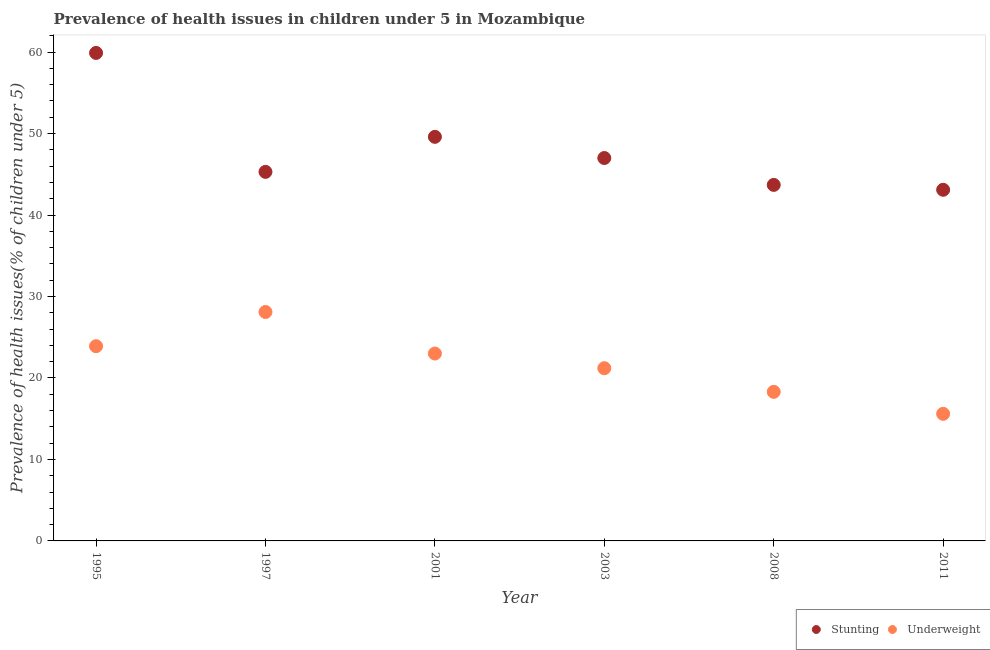Is the number of dotlines equal to the number of legend labels?
Your answer should be compact. Yes. What is the percentage of underweight children in 2001?
Your response must be concise. 23. Across all years, what is the maximum percentage of stunted children?
Keep it short and to the point. 59.9. Across all years, what is the minimum percentage of underweight children?
Make the answer very short. 15.6. In which year was the percentage of stunted children maximum?
Your answer should be very brief. 1995. What is the total percentage of stunted children in the graph?
Provide a succinct answer. 288.6. What is the difference between the percentage of underweight children in 1997 and that in 2001?
Offer a very short reply. 5.1. What is the average percentage of stunted children per year?
Give a very brief answer. 48.1. In the year 2003, what is the difference between the percentage of stunted children and percentage of underweight children?
Ensure brevity in your answer.  25.8. What is the ratio of the percentage of underweight children in 2001 to that in 2011?
Ensure brevity in your answer.  1.47. Is the difference between the percentage of underweight children in 1995 and 2001 greater than the difference between the percentage of stunted children in 1995 and 2001?
Make the answer very short. No. What is the difference between the highest and the second highest percentage of stunted children?
Ensure brevity in your answer.  10.3. What is the difference between the highest and the lowest percentage of underweight children?
Your answer should be compact. 12.5. In how many years, is the percentage of underweight children greater than the average percentage of underweight children taken over all years?
Keep it short and to the point. 3. Does the percentage of stunted children monotonically increase over the years?
Keep it short and to the point. No. How many dotlines are there?
Offer a very short reply. 2. What is the difference between two consecutive major ticks on the Y-axis?
Provide a short and direct response. 10. Does the graph contain any zero values?
Keep it short and to the point. No. Where does the legend appear in the graph?
Make the answer very short. Bottom right. How many legend labels are there?
Give a very brief answer. 2. How are the legend labels stacked?
Offer a terse response. Horizontal. What is the title of the graph?
Provide a succinct answer. Prevalence of health issues in children under 5 in Mozambique. What is the label or title of the Y-axis?
Offer a terse response. Prevalence of health issues(% of children under 5). What is the Prevalence of health issues(% of children under 5) in Stunting in 1995?
Your response must be concise. 59.9. What is the Prevalence of health issues(% of children under 5) of Underweight in 1995?
Your response must be concise. 23.9. What is the Prevalence of health issues(% of children under 5) of Stunting in 1997?
Give a very brief answer. 45.3. What is the Prevalence of health issues(% of children under 5) of Underweight in 1997?
Offer a very short reply. 28.1. What is the Prevalence of health issues(% of children under 5) in Stunting in 2001?
Your answer should be very brief. 49.6. What is the Prevalence of health issues(% of children under 5) in Stunting in 2003?
Offer a terse response. 47. What is the Prevalence of health issues(% of children under 5) of Underweight in 2003?
Keep it short and to the point. 21.2. What is the Prevalence of health issues(% of children under 5) in Stunting in 2008?
Give a very brief answer. 43.7. What is the Prevalence of health issues(% of children under 5) of Underweight in 2008?
Offer a very short reply. 18.3. What is the Prevalence of health issues(% of children under 5) in Stunting in 2011?
Give a very brief answer. 43.1. What is the Prevalence of health issues(% of children under 5) in Underweight in 2011?
Ensure brevity in your answer.  15.6. Across all years, what is the maximum Prevalence of health issues(% of children under 5) in Stunting?
Give a very brief answer. 59.9. Across all years, what is the maximum Prevalence of health issues(% of children under 5) in Underweight?
Make the answer very short. 28.1. Across all years, what is the minimum Prevalence of health issues(% of children under 5) in Stunting?
Your answer should be very brief. 43.1. Across all years, what is the minimum Prevalence of health issues(% of children under 5) of Underweight?
Your answer should be very brief. 15.6. What is the total Prevalence of health issues(% of children under 5) in Stunting in the graph?
Keep it short and to the point. 288.6. What is the total Prevalence of health issues(% of children under 5) of Underweight in the graph?
Provide a succinct answer. 130.1. What is the difference between the Prevalence of health issues(% of children under 5) in Stunting in 1995 and that in 1997?
Provide a short and direct response. 14.6. What is the difference between the Prevalence of health issues(% of children under 5) of Stunting in 1995 and that in 2003?
Provide a short and direct response. 12.9. What is the difference between the Prevalence of health issues(% of children under 5) in Underweight in 1995 and that in 2008?
Your answer should be compact. 5.6. What is the difference between the Prevalence of health issues(% of children under 5) of Underweight in 1995 and that in 2011?
Your response must be concise. 8.3. What is the difference between the Prevalence of health issues(% of children under 5) in Stunting in 1997 and that in 2001?
Your response must be concise. -4.3. What is the difference between the Prevalence of health issues(% of children under 5) in Underweight in 1997 and that in 2001?
Provide a short and direct response. 5.1. What is the difference between the Prevalence of health issues(% of children under 5) of Stunting in 1997 and that in 2003?
Your answer should be compact. -1.7. What is the difference between the Prevalence of health issues(% of children under 5) in Underweight in 1997 and that in 2008?
Your answer should be very brief. 9.8. What is the difference between the Prevalence of health issues(% of children under 5) of Stunting in 1997 and that in 2011?
Keep it short and to the point. 2.2. What is the difference between the Prevalence of health issues(% of children under 5) of Underweight in 1997 and that in 2011?
Provide a succinct answer. 12.5. What is the difference between the Prevalence of health issues(% of children under 5) of Stunting in 2001 and that in 2003?
Your answer should be compact. 2.6. What is the difference between the Prevalence of health issues(% of children under 5) in Underweight in 2001 and that in 2003?
Your response must be concise. 1.8. What is the difference between the Prevalence of health issues(% of children under 5) in Stunting in 2001 and that in 2008?
Give a very brief answer. 5.9. What is the difference between the Prevalence of health issues(% of children under 5) in Underweight in 2001 and that in 2008?
Make the answer very short. 4.7. What is the difference between the Prevalence of health issues(% of children under 5) of Underweight in 2001 and that in 2011?
Your answer should be very brief. 7.4. What is the difference between the Prevalence of health issues(% of children under 5) in Stunting in 2003 and that in 2008?
Ensure brevity in your answer.  3.3. What is the difference between the Prevalence of health issues(% of children under 5) in Stunting in 2003 and that in 2011?
Your response must be concise. 3.9. What is the difference between the Prevalence of health issues(% of children under 5) in Underweight in 2003 and that in 2011?
Keep it short and to the point. 5.6. What is the difference between the Prevalence of health issues(% of children under 5) in Underweight in 2008 and that in 2011?
Offer a very short reply. 2.7. What is the difference between the Prevalence of health issues(% of children under 5) of Stunting in 1995 and the Prevalence of health issues(% of children under 5) of Underweight in 1997?
Ensure brevity in your answer.  31.8. What is the difference between the Prevalence of health issues(% of children under 5) in Stunting in 1995 and the Prevalence of health issues(% of children under 5) in Underweight in 2001?
Offer a terse response. 36.9. What is the difference between the Prevalence of health issues(% of children under 5) of Stunting in 1995 and the Prevalence of health issues(% of children under 5) of Underweight in 2003?
Your answer should be very brief. 38.7. What is the difference between the Prevalence of health issues(% of children under 5) in Stunting in 1995 and the Prevalence of health issues(% of children under 5) in Underweight in 2008?
Provide a succinct answer. 41.6. What is the difference between the Prevalence of health issues(% of children under 5) in Stunting in 1995 and the Prevalence of health issues(% of children under 5) in Underweight in 2011?
Provide a succinct answer. 44.3. What is the difference between the Prevalence of health issues(% of children under 5) of Stunting in 1997 and the Prevalence of health issues(% of children under 5) of Underweight in 2001?
Make the answer very short. 22.3. What is the difference between the Prevalence of health issues(% of children under 5) of Stunting in 1997 and the Prevalence of health issues(% of children under 5) of Underweight in 2003?
Your answer should be compact. 24.1. What is the difference between the Prevalence of health issues(% of children under 5) in Stunting in 1997 and the Prevalence of health issues(% of children under 5) in Underweight in 2008?
Make the answer very short. 27. What is the difference between the Prevalence of health issues(% of children under 5) in Stunting in 1997 and the Prevalence of health issues(% of children under 5) in Underweight in 2011?
Give a very brief answer. 29.7. What is the difference between the Prevalence of health issues(% of children under 5) of Stunting in 2001 and the Prevalence of health issues(% of children under 5) of Underweight in 2003?
Your answer should be very brief. 28.4. What is the difference between the Prevalence of health issues(% of children under 5) of Stunting in 2001 and the Prevalence of health issues(% of children under 5) of Underweight in 2008?
Ensure brevity in your answer.  31.3. What is the difference between the Prevalence of health issues(% of children under 5) of Stunting in 2003 and the Prevalence of health issues(% of children under 5) of Underweight in 2008?
Your response must be concise. 28.7. What is the difference between the Prevalence of health issues(% of children under 5) of Stunting in 2003 and the Prevalence of health issues(% of children under 5) of Underweight in 2011?
Your answer should be compact. 31.4. What is the difference between the Prevalence of health issues(% of children under 5) in Stunting in 2008 and the Prevalence of health issues(% of children under 5) in Underweight in 2011?
Make the answer very short. 28.1. What is the average Prevalence of health issues(% of children under 5) of Stunting per year?
Keep it short and to the point. 48.1. What is the average Prevalence of health issues(% of children under 5) in Underweight per year?
Your answer should be compact. 21.68. In the year 1995, what is the difference between the Prevalence of health issues(% of children under 5) of Stunting and Prevalence of health issues(% of children under 5) of Underweight?
Your response must be concise. 36. In the year 2001, what is the difference between the Prevalence of health issues(% of children under 5) of Stunting and Prevalence of health issues(% of children under 5) of Underweight?
Ensure brevity in your answer.  26.6. In the year 2003, what is the difference between the Prevalence of health issues(% of children under 5) of Stunting and Prevalence of health issues(% of children under 5) of Underweight?
Make the answer very short. 25.8. In the year 2008, what is the difference between the Prevalence of health issues(% of children under 5) in Stunting and Prevalence of health issues(% of children under 5) in Underweight?
Ensure brevity in your answer.  25.4. What is the ratio of the Prevalence of health issues(% of children under 5) in Stunting in 1995 to that in 1997?
Ensure brevity in your answer.  1.32. What is the ratio of the Prevalence of health issues(% of children under 5) of Underweight in 1995 to that in 1997?
Your answer should be very brief. 0.85. What is the ratio of the Prevalence of health issues(% of children under 5) in Stunting in 1995 to that in 2001?
Offer a terse response. 1.21. What is the ratio of the Prevalence of health issues(% of children under 5) of Underweight in 1995 to that in 2001?
Provide a succinct answer. 1.04. What is the ratio of the Prevalence of health issues(% of children under 5) of Stunting in 1995 to that in 2003?
Offer a terse response. 1.27. What is the ratio of the Prevalence of health issues(% of children under 5) in Underweight in 1995 to that in 2003?
Provide a succinct answer. 1.13. What is the ratio of the Prevalence of health issues(% of children under 5) of Stunting in 1995 to that in 2008?
Keep it short and to the point. 1.37. What is the ratio of the Prevalence of health issues(% of children under 5) in Underweight in 1995 to that in 2008?
Provide a short and direct response. 1.31. What is the ratio of the Prevalence of health issues(% of children under 5) in Stunting in 1995 to that in 2011?
Give a very brief answer. 1.39. What is the ratio of the Prevalence of health issues(% of children under 5) in Underweight in 1995 to that in 2011?
Keep it short and to the point. 1.53. What is the ratio of the Prevalence of health issues(% of children under 5) of Stunting in 1997 to that in 2001?
Offer a very short reply. 0.91. What is the ratio of the Prevalence of health issues(% of children under 5) in Underweight in 1997 to that in 2001?
Keep it short and to the point. 1.22. What is the ratio of the Prevalence of health issues(% of children under 5) in Stunting in 1997 to that in 2003?
Your response must be concise. 0.96. What is the ratio of the Prevalence of health issues(% of children under 5) in Underweight in 1997 to that in 2003?
Give a very brief answer. 1.33. What is the ratio of the Prevalence of health issues(% of children under 5) of Stunting in 1997 to that in 2008?
Keep it short and to the point. 1.04. What is the ratio of the Prevalence of health issues(% of children under 5) of Underweight in 1997 to that in 2008?
Your answer should be very brief. 1.54. What is the ratio of the Prevalence of health issues(% of children under 5) in Stunting in 1997 to that in 2011?
Your response must be concise. 1.05. What is the ratio of the Prevalence of health issues(% of children under 5) of Underweight in 1997 to that in 2011?
Ensure brevity in your answer.  1.8. What is the ratio of the Prevalence of health issues(% of children under 5) of Stunting in 2001 to that in 2003?
Ensure brevity in your answer.  1.06. What is the ratio of the Prevalence of health issues(% of children under 5) of Underweight in 2001 to that in 2003?
Your response must be concise. 1.08. What is the ratio of the Prevalence of health issues(% of children under 5) of Stunting in 2001 to that in 2008?
Ensure brevity in your answer.  1.14. What is the ratio of the Prevalence of health issues(% of children under 5) in Underweight in 2001 to that in 2008?
Give a very brief answer. 1.26. What is the ratio of the Prevalence of health issues(% of children under 5) of Stunting in 2001 to that in 2011?
Ensure brevity in your answer.  1.15. What is the ratio of the Prevalence of health issues(% of children under 5) in Underweight in 2001 to that in 2011?
Your response must be concise. 1.47. What is the ratio of the Prevalence of health issues(% of children under 5) of Stunting in 2003 to that in 2008?
Provide a succinct answer. 1.08. What is the ratio of the Prevalence of health issues(% of children under 5) in Underweight in 2003 to that in 2008?
Your response must be concise. 1.16. What is the ratio of the Prevalence of health issues(% of children under 5) of Stunting in 2003 to that in 2011?
Give a very brief answer. 1.09. What is the ratio of the Prevalence of health issues(% of children under 5) of Underweight in 2003 to that in 2011?
Offer a terse response. 1.36. What is the ratio of the Prevalence of health issues(% of children under 5) in Stunting in 2008 to that in 2011?
Your answer should be compact. 1.01. What is the ratio of the Prevalence of health issues(% of children under 5) of Underweight in 2008 to that in 2011?
Your answer should be very brief. 1.17. What is the difference between the highest and the second highest Prevalence of health issues(% of children under 5) of Stunting?
Keep it short and to the point. 10.3. What is the difference between the highest and the second highest Prevalence of health issues(% of children under 5) in Underweight?
Ensure brevity in your answer.  4.2. 